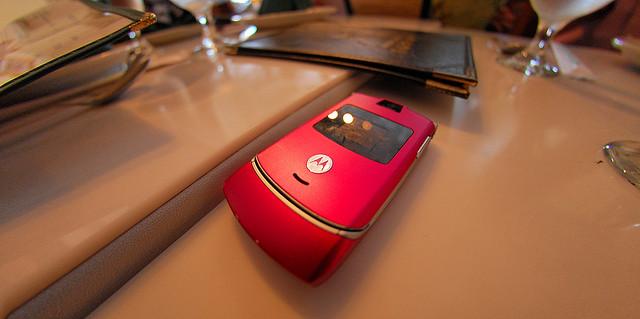Where is this scene taking place?
Quick response, please. Table. What color is the phone?
Keep it brief. Red. Is the cell phone open or closed?
Be succinct. Closed. 